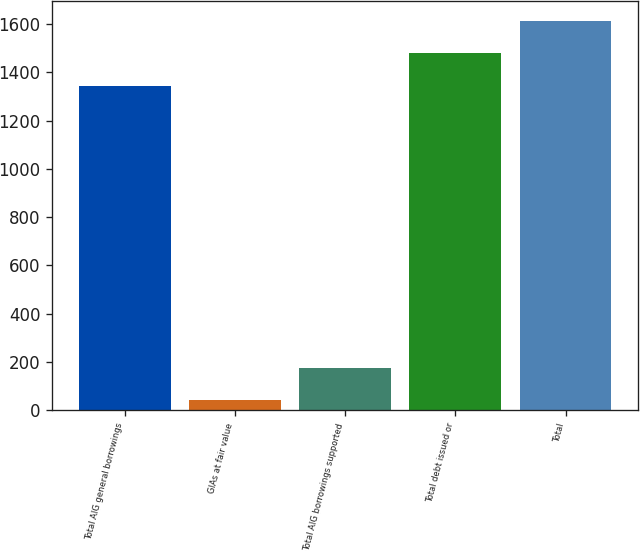Convert chart to OTSL. <chart><loc_0><loc_0><loc_500><loc_500><bar_chart><fcel>Total AIG general borrowings<fcel>GIAs at fair value<fcel>Total AIG borrowings supported<fcel>Total debt issued or<fcel>Total<nl><fcel>1345<fcel>41<fcel>175.5<fcel>1479.5<fcel>1614<nl></chart> 